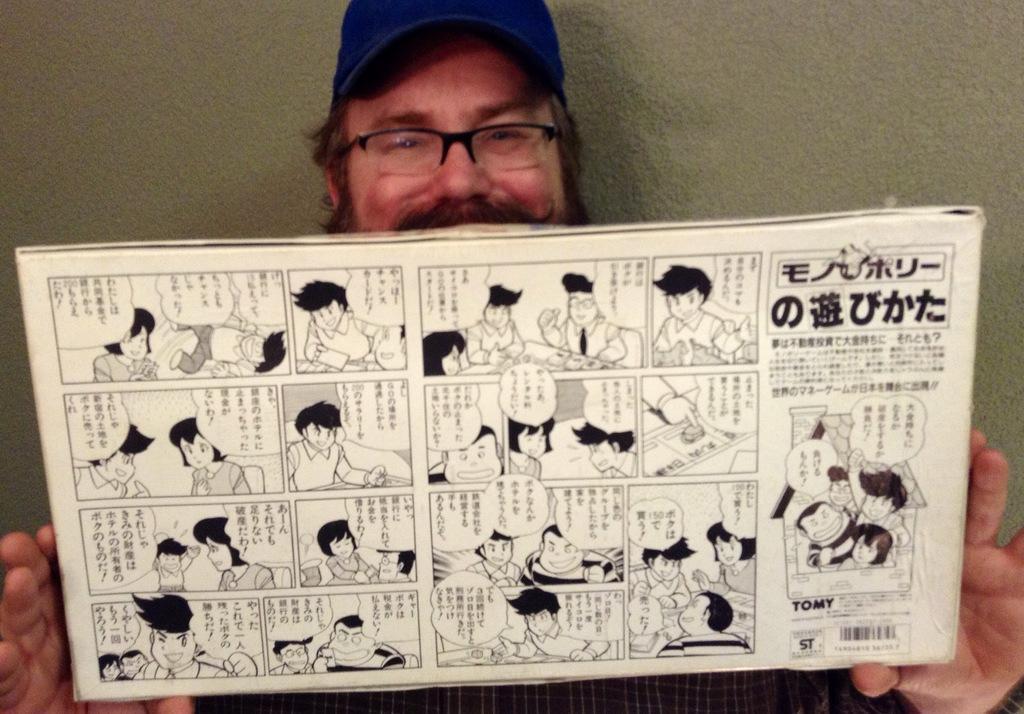How would you summarize this image in a sentence or two? In this image, we can see a person is watching and holding a board. He is wearing glasses and cap. On the board, we can see few figures, text and barcode. In the background, there is a wall. 